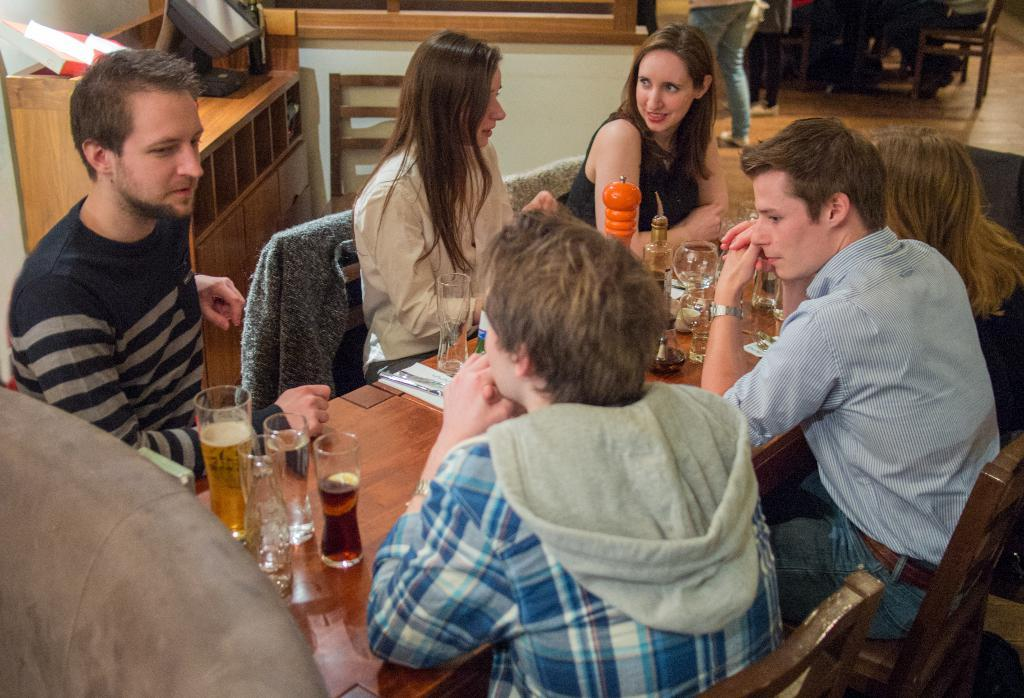What are the people in the image doing? There is a group of people sitting on chairs in the image. What is on the table in the image? There are glass tumblers and bottles on the table in the image. Can you describe the monitor screen in the image? The monitor screen is in the image and is placed on a rack. What type of flesh can be seen on the monitor screen in the image? There is no flesh visible on the monitor screen in the image. How does the robin interact with the bottles on the table in the image? There is no robin present in the image; it only features a group of people sitting on chairs, a table, glass tumblers, bottles, and a monitor screen on a rack. 